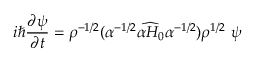<formula> <loc_0><loc_0><loc_500><loc_500>i \hbar { } \partial \psi } { \partial t } = { \rho } ^ { - 1 / 2 } ( \alpha ^ { - 1 / 2 } \widehat { \alpha H _ { 0 } } \alpha ^ { - 1 / 2 } ) { \rho } ^ { 1 / 2 } \ \psi</formula> 